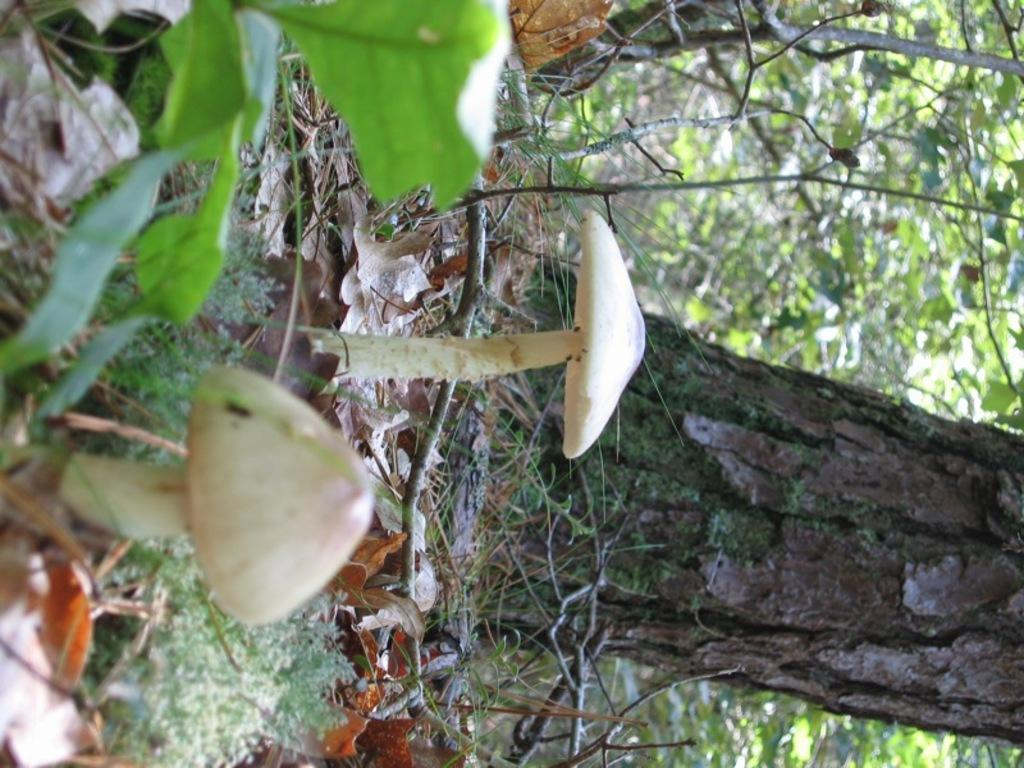What type of vegetation can be seen on the ground in the image? There are mushrooms on the ground in the image. What other natural elements can be seen in the image? There are trees and a plant visible in the image. What is covering the ground along with the mushrooms? Dry leaves are present on the ground. What hobbies are the mushrooms participating in during the test in the image? There are no mushrooms participating in any hobbies or tests in the image; they are simply growing on the ground. 